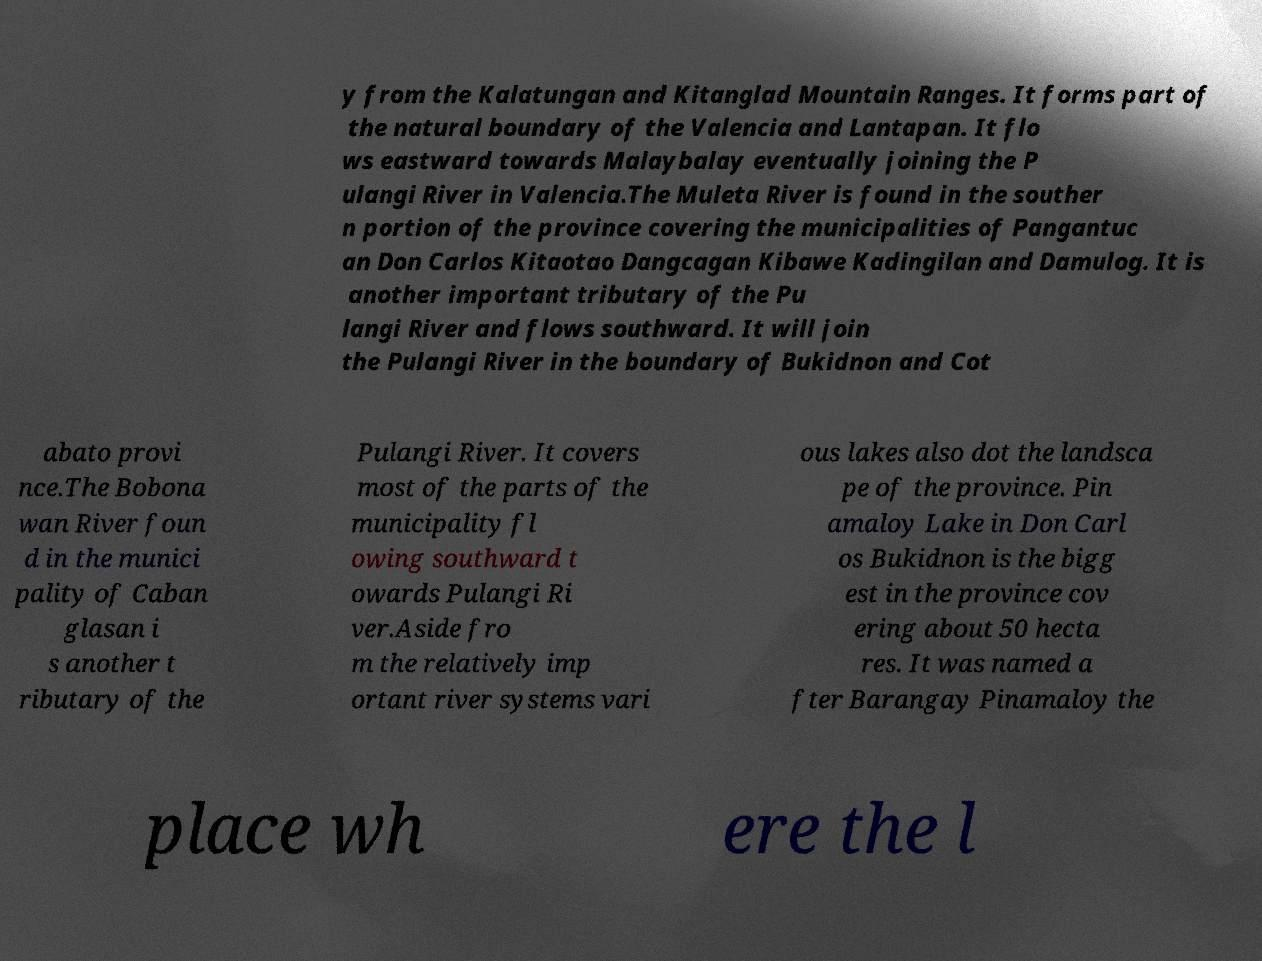I need the written content from this picture converted into text. Can you do that? y from the Kalatungan and Kitanglad Mountain Ranges. It forms part of the natural boundary of the Valencia and Lantapan. It flo ws eastward towards Malaybalay eventually joining the P ulangi River in Valencia.The Muleta River is found in the souther n portion of the province covering the municipalities of Pangantuc an Don Carlos Kitaotao Dangcagan Kibawe Kadingilan and Damulog. It is another important tributary of the Pu langi River and flows southward. It will join the Pulangi River in the boundary of Bukidnon and Cot abato provi nce.The Bobona wan River foun d in the munici pality of Caban glasan i s another t ributary of the Pulangi River. It covers most of the parts of the municipality fl owing southward t owards Pulangi Ri ver.Aside fro m the relatively imp ortant river systems vari ous lakes also dot the landsca pe of the province. Pin amaloy Lake in Don Carl os Bukidnon is the bigg est in the province cov ering about 50 hecta res. It was named a fter Barangay Pinamaloy the place wh ere the l 